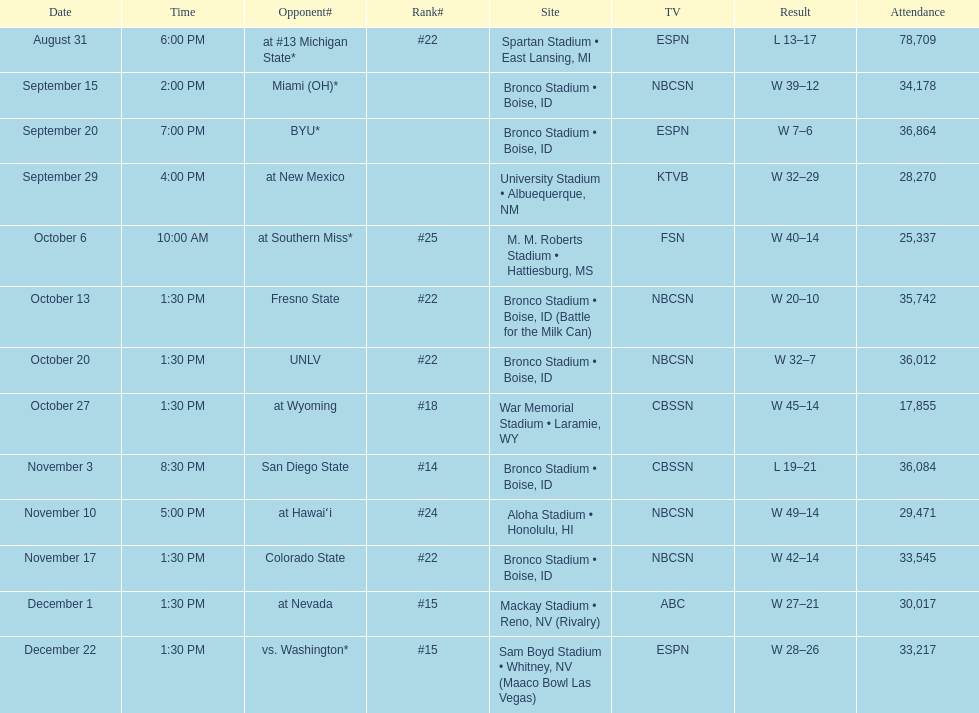Could you parse the entire table? {'header': ['Date', 'Time', 'Opponent#', 'Rank#', 'Site', 'TV', 'Result', 'Attendance'], 'rows': [['August 31', '6:00 PM', 'at\xa0#13\xa0Michigan State*', '#22', 'Spartan Stadium • East Lansing, MI', 'ESPN', 'L\xa013–17', '78,709'], ['September 15', '2:00 PM', 'Miami (OH)*', '', 'Bronco Stadium • Boise, ID', 'NBCSN', 'W\xa039–12', '34,178'], ['September 20', '7:00 PM', 'BYU*', '', 'Bronco Stadium • Boise, ID', 'ESPN', 'W\xa07–6', '36,864'], ['September 29', '4:00 PM', 'at\xa0New Mexico', '', 'University Stadium • Albuequerque, NM', 'KTVB', 'W\xa032–29', '28,270'], ['October 6', '10:00 AM', 'at\xa0Southern Miss*', '#25', 'M. M. Roberts Stadium • Hattiesburg, MS', 'FSN', 'W\xa040–14', '25,337'], ['October 13', '1:30 PM', 'Fresno State', '#22', 'Bronco Stadium • Boise, ID (Battle for the Milk Can)', 'NBCSN', 'W\xa020–10', '35,742'], ['October 20', '1:30 PM', 'UNLV', '#22', 'Bronco Stadium • Boise, ID', 'NBCSN', 'W\xa032–7', '36,012'], ['October 27', '1:30 PM', 'at\xa0Wyoming', '#18', 'War Memorial Stadium • Laramie, WY', 'CBSSN', 'W\xa045–14', '17,855'], ['November 3', '8:30 PM', 'San Diego State', '#14', 'Bronco Stadium • Boise, ID', 'CBSSN', 'L\xa019–21', '36,084'], ['November 10', '5:00 PM', 'at\xa0Hawaiʻi', '#24', 'Aloha Stadium • Honolulu, HI', 'NBCSN', 'W\xa049–14', '29,471'], ['November 17', '1:30 PM', 'Colorado State', '#22', 'Bronco Stadium • Boise, ID', 'NBCSN', 'W\xa042–14', '33,545'], ['December 1', '1:30 PM', 'at\xa0Nevada', '#15', 'Mackay Stadium • Reno, NV (Rivalry)', 'ABC', 'W\xa027–21', '30,017'], ['December 22', '1:30 PM', 'vs.\xa0Washington*', '#15', 'Sam Boyd Stadium • Whitney, NV (Maaco Bowl Las Vegas)', 'ESPN', 'W\xa028–26', '33,217']]} What rank was boise state after november 10th? #22. 